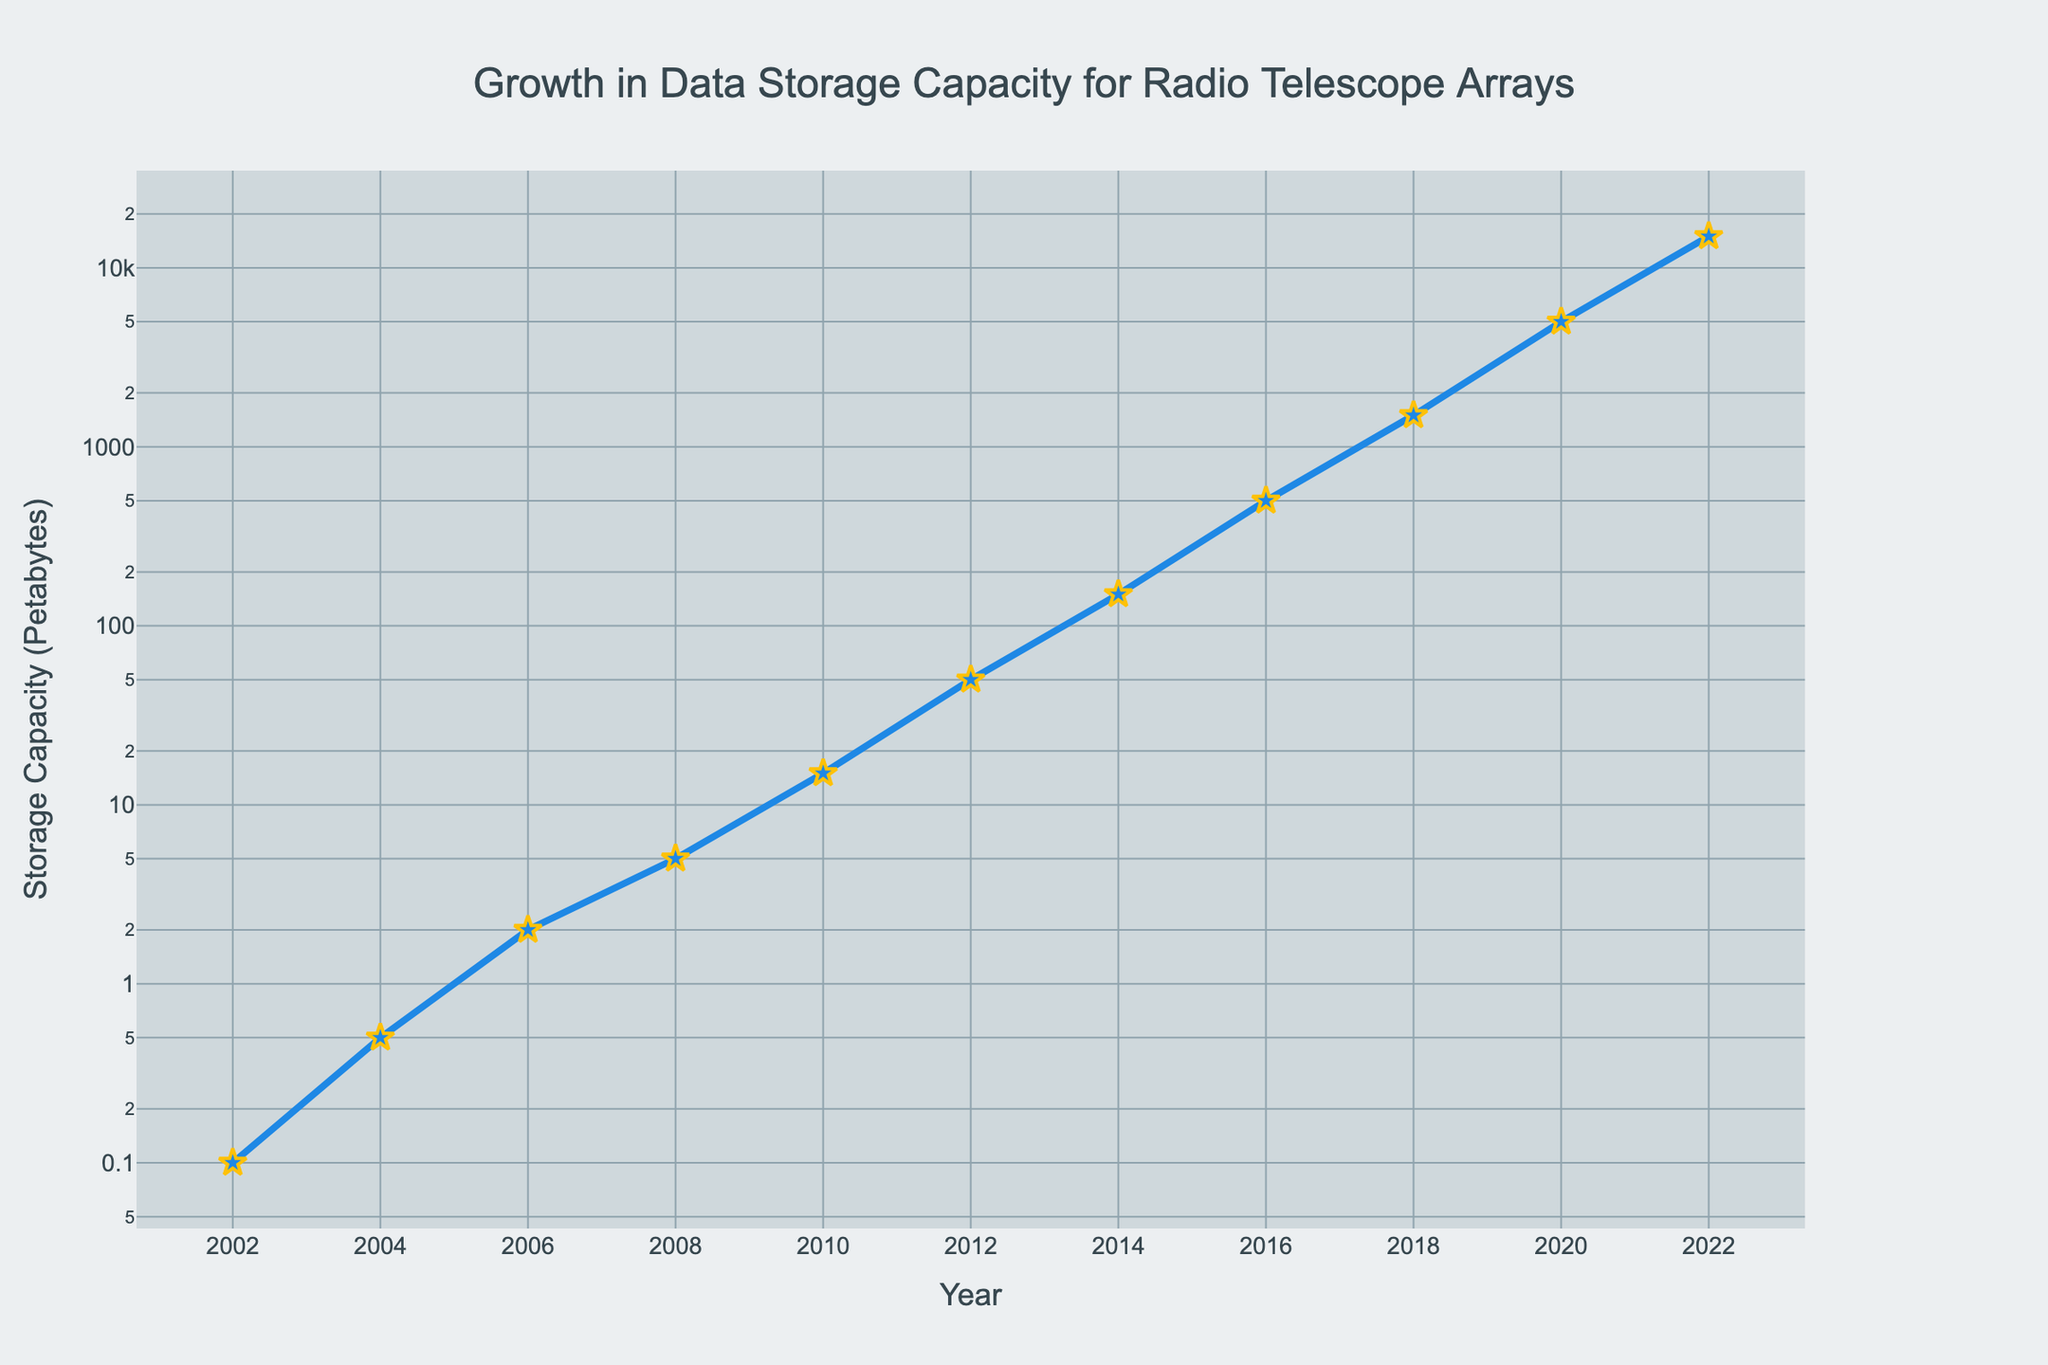Which year saw the initial exponential growth in data storage capacity? The plot shows a significant change in the slope of the line from around 2010 onward, indicating exponential growth in data storage capacity.
Answer: 2010 What's the total increase in data storage capacity from 2002 to 2022? The initial capacity in 2002 is 0.1 petabytes, and the final capacity in 2022 is 15,000 petabytes. Subtract the initial from the final value: 15000 - 0.1 = 14999.9 petabytes.
Answer: 14999.9 Which year had a storage capacity of 50 petabytes? By looking at the plot, the point at which the storage capacity reaches 50 petabytes is marked at the year 2012.
Answer: 2012 How does the storage capacity in 2018 compare to the capacity in 2008? The storage capacity in 2018 is 1500 petabytes, and in 2008 it is 5 petabytes. Comparing the two, we see that 1500 is greater than 5.
Answer: 2018's capacity is greater If the trend continues, predict the storage capacity for the year 2024. Observing the exponential growth pattern, each year doubles or even triples the previous capacity. If the trend continues, the 2024 capacity could be estimated by multiplying the 2022 capacity (15,000 petabytes) by an approximate factor. Assuming a tripling factor: 15000 * 3 ≈ 45000 petabytes.
Answer: Approximately 45,000 petabytes In which year did the storage capacity first exceed 100 petabytes? By checking the plot, the first year in which the capacity exceeds 100 petabytes is noted in 2014 when it reaches 150 petabytes.
Answer: 2014 What is the average storage capacity increase per year from 2002 to 2022? The total increase over these years is 14999.9 petabytes over 20 years. So, the average increase per year is 14999.9 / 20 = 749.995 petabytes.
Answer: 749.995 Which two consecutive years have the steepest growth in storage capacity? The steepest growth is identified by the largest gap between consecutive data points. From 2020 (5000 petabytes) to 2022 (15000 petabytes) has the largest difference: 15000 - 5000 = 10000 petabytes.
Answer: 2020 to 2022 What visual attributes emphasize the exponential growth in the plot? The line becomes significantly steeper from 2010 onwards, thick blue line and orange markers highlight it, and an annotation at 2022 emphasizing "Exponential growth".
Answer: Steep line and annotation Compare the storage capacity in 2010 to that in 2012. How much more storage capacity was available in 2012? In 2010, the capacity was 15 petabytes and in 2012, it was 50 petabytes. The difference is 50 - 15 = 35 petabytes.
Answer: 35 more petabytes 